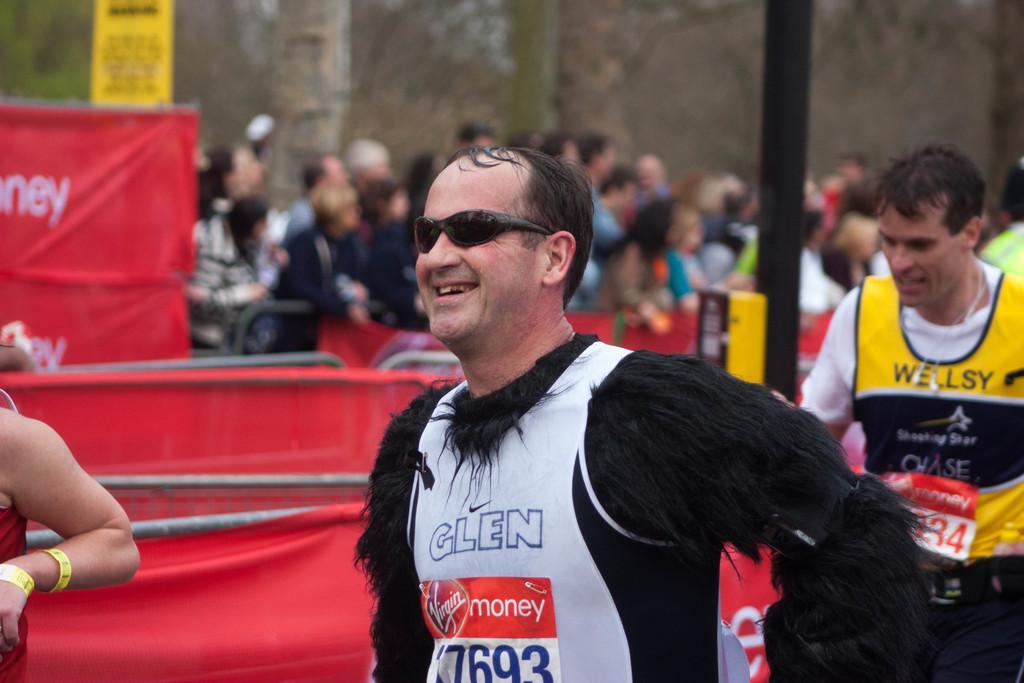Could you give a brief overview of what you see in this image? In this image I can see few people are wearing different color dresses. Back I can see few red cloth, poles, signboards and background is blurred. 